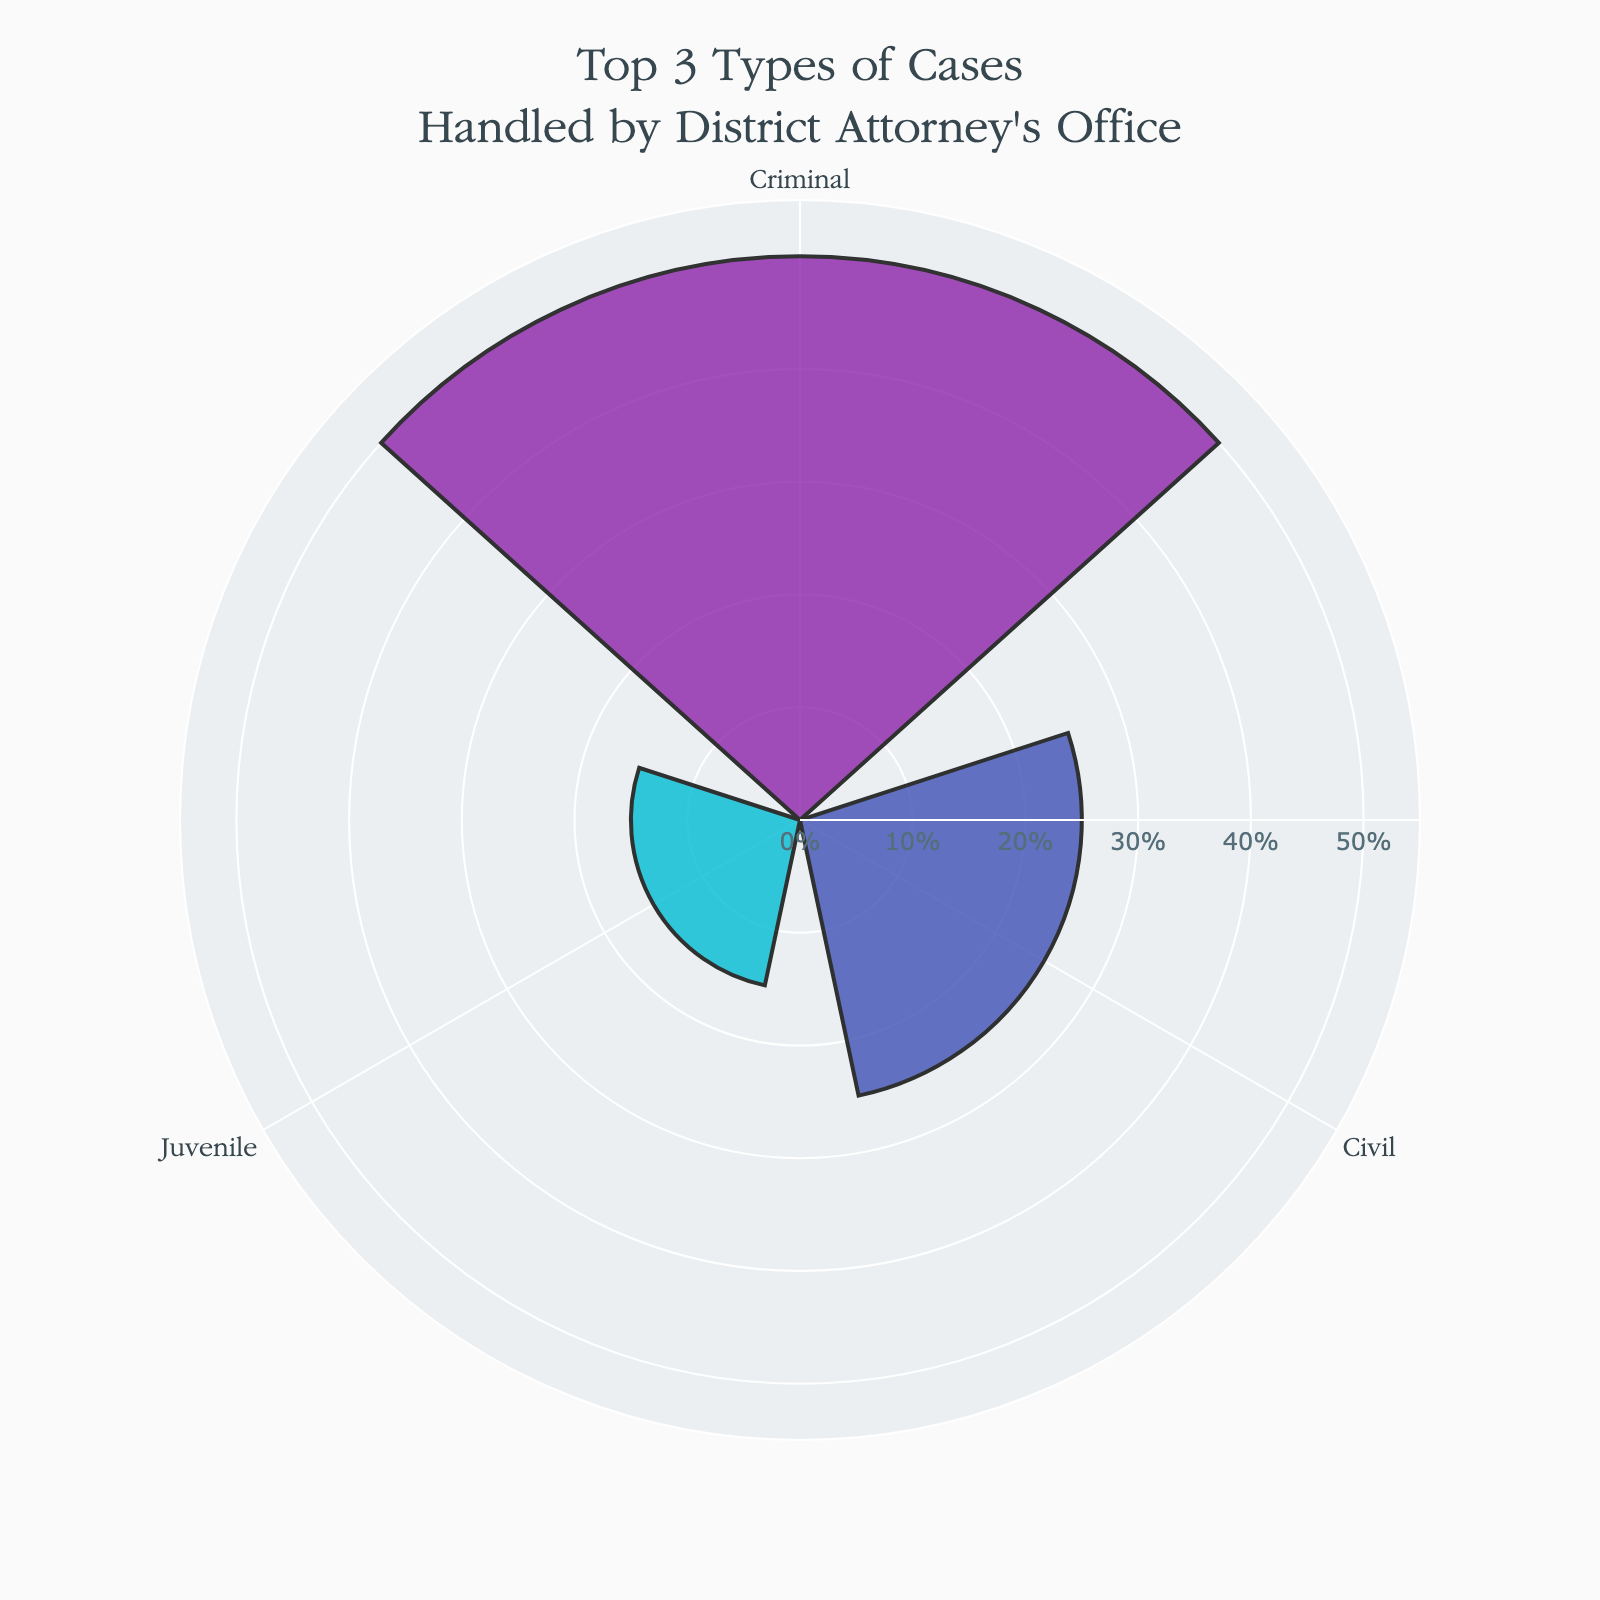What is the title of the chart? The chart's title is located at the top of the figure, written in larger text.
Answer: "Top 3 Types of Cases Handled by District Attorney's Office" How many main categories are displayed in the chart? The rose chart shows three distinct colored segments, each representing a category.
Answer: 3 Which category has the highest percentage? By observing which section of the rose chart has the longest radius, one can conclude the category with the highest percentage.
Answer: Criminal What's the difference between the highest and lowest category percentages? The highest percentage is 50% (Criminal) and the lowest in the chart is 15% (Juvenile). The difference is calculated as 50% - 15%.
Answer: 35% What is the color used to represent the Civil category in the chart? Each category in the chart is represented with a distinct color. The Civil category is marked with a bluish hue.
Answer: Blue What is the combined percentage of Civil and Juvenile categories? Add the percentages of Civil (25%) and Juvenile (15%) categories to get the combined value.
Answer: 40% Among the three categories shown, which one has the smallest percentage? By examining which section of the rose chart has the shortest radius, one can identify the category with the smallest percentage.
Answer: Juvenile Are there any categories represented that have less than 20%? By looking at the segments, we see that the Juvenile category has 15% which is less than 20%.
Answer: Yes, Juvenile What's the average percentage of the categories shown in the chart? Summing the percentages of the three categories (50%, 25%, and 15%) gives 90%. The average is calculated by dividing 90% by the number of categories (3).
Answer: 30% Which category in the chart is second in terms of percentage? Comparing the lengths of the segments, we find the second-longest segment indicates the Civil category.
Answer: Civil 